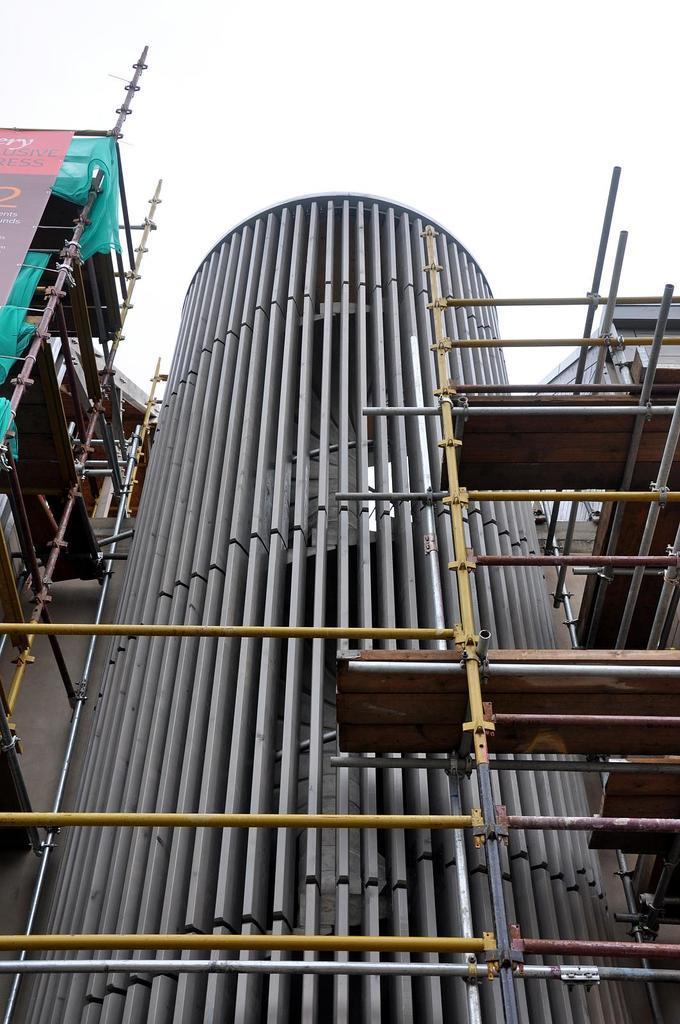How would you summarize this image in a sentence or two? In this image I can see a building which is under construction, a banner and a green colored cloth to the building. I can see few metal rods and few wooden surfaces on rods. In the background I can see the sky. 